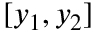Convert formula to latex. <formula><loc_0><loc_0><loc_500><loc_500>[ y _ { 1 } , y _ { 2 } ]</formula> 